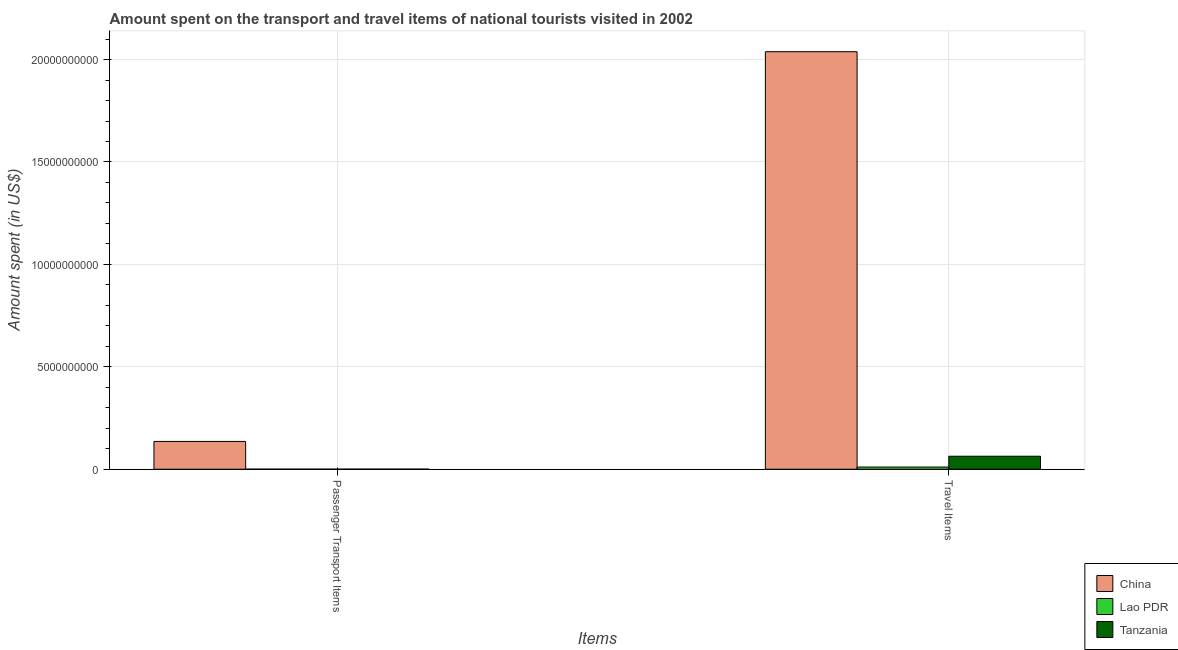Are the number of bars per tick equal to the number of legend labels?
Your answer should be compact. Yes. How many bars are there on the 2nd tick from the left?
Provide a succinct answer. 3. How many bars are there on the 1st tick from the right?
Ensure brevity in your answer.  3. What is the label of the 2nd group of bars from the left?
Provide a succinct answer. Travel Items. What is the amount spent on passenger transport items in China?
Provide a succinct answer. 1.36e+09. Across all countries, what is the maximum amount spent on passenger transport items?
Your answer should be compact. 1.36e+09. Across all countries, what is the minimum amount spent on passenger transport items?
Give a very brief answer. 3.00e+06. In which country was the amount spent on passenger transport items minimum?
Offer a terse response. Lao PDR. What is the total amount spent in travel items in the graph?
Ensure brevity in your answer.  2.11e+1. What is the difference between the amount spent on passenger transport items in China and that in Lao PDR?
Ensure brevity in your answer.  1.35e+09. What is the difference between the amount spent in travel items in Lao PDR and the amount spent on passenger transport items in Tanzania?
Offer a terse response. 1.03e+08. What is the average amount spent on passenger transport items per country?
Ensure brevity in your answer.  4.55e+08. What is the difference between the amount spent on passenger transport items and amount spent in travel items in China?
Ensure brevity in your answer.  -1.90e+1. In how many countries, is the amount spent on passenger transport items greater than 19000000000 US$?
Give a very brief answer. 0. What is the ratio of the amount spent on passenger transport items in Tanzania to that in Lao PDR?
Offer a very short reply. 1.33. What does the 1st bar from the left in Travel Items represents?
Give a very brief answer. China. What does the 3rd bar from the right in Travel Items represents?
Keep it short and to the point. China. How many bars are there?
Your answer should be very brief. 6. Are all the bars in the graph horizontal?
Your answer should be very brief. No. How many countries are there in the graph?
Provide a succinct answer. 3. Does the graph contain any zero values?
Keep it short and to the point. No. Where does the legend appear in the graph?
Your answer should be very brief. Bottom right. What is the title of the graph?
Your answer should be compact. Amount spent on the transport and travel items of national tourists visited in 2002. Does "St. Martin (French part)" appear as one of the legend labels in the graph?
Ensure brevity in your answer.  No. What is the label or title of the X-axis?
Provide a short and direct response. Items. What is the label or title of the Y-axis?
Make the answer very short. Amount spent (in US$). What is the Amount spent (in US$) in China in Passenger Transport Items?
Offer a very short reply. 1.36e+09. What is the Amount spent (in US$) in Lao PDR in Passenger Transport Items?
Offer a very short reply. 3.00e+06. What is the Amount spent (in US$) in China in Travel Items?
Provide a succinct answer. 2.04e+1. What is the Amount spent (in US$) of Lao PDR in Travel Items?
Ensure brevity in your answer.  1.07e+08. What is the Amount spent (in US$) of Tanzania in Travel Items?
Your answer should be very brief. 6.35e+08. Across all Items, what is the maximum Amount spent (in US$) of China?
Make the answer very short. 2.04e+1. Across all Items, what is the maximum Amount spent (in US$) of Lao PDR?
Your response must be concise. 1.07e+08. Across all Items, what is the maximum Amount spent (in US$) in Tanzania?
Provide a short and direct response. 6.35e+08. Across all Items, what is the minimum Amount spent (in US$) in China?
Make the answer very short. 1.36e+09. Across all Items, what is the minimum Amount spent (in US$) in Lao PDR?
Keep it short and to the point. 3.00e+06. Across all Items, what is the minimum Amount spent (in US$) of Tanzania?
Keep it short and to the point. 4.00e+06. What is the total Amount spent (in US$) of China in the graph?
Provide a succinct answer. 2.17e+1. What is the total Amount spent (in US$) of Lao PDR in the graph?
Offer a terse response. 1.10e+08. What is the total Amount spent (in US$) in Tanzania in the graph?
Provide a short and direct response. 6.39e+08. What is the difference between the Amount spent (in US$) in China in Passenger Transport Items and that in Travel Items?
Provide a short and direct response. -1.90e+1. What is the difference between the Amount spent (in US$) in Lao PDR in Passenger Transport Items and that in Travel Items?
Offer a very short reply. -1.04e+08. What is the difference between the Amount spent (in US$) in Tanzania in Passenger Transport Items and that in Travel Items?
Offer a very short reply. -6.31e+08. What is the difference between the Amount spent (in US$) in China in Passenger Transport Items and the Amount spent (in US$) in Lao PDR in Travel Items?
Your answer should be very brief. 1.25e+09. What is the difference between the Amount spent (in US$) of China in Passenger Transport Items and the Amount spent (in US$) of Tanzania in Travel Items?
Ensure brevity in your answer.  7.22e+08. What is the difference between the Amount spent (in US$) in Lao PDR in Passenger Transport Items and the Amount spent (in US$) in Tanzania in Travel Items?
Make the answer very short. -6.32e+08. What is the average Amount spent (in US$) in China per Items?
Offer a very short reply. 1.09e+1. What is the average Amount spent (in US$) of Lao PDR per Items?
Provide a succinct answer. 5.50e+07. What is the average Amount spent (in US$) of Tanzania per Items?
Keep it short and to the point. 3.20e+08. What is the difference between the Amount spent (in US$) of China and Amount spent (in US$) of Lao PDR in Passenger Transport Items?
Ensure brevity in your answer.  1.35e+09. What is the difference between the Amount spent (in US$) in China and Amount spent (in US$) in Tanzania in Passenger Transport Items?
Offer a very short reply. 1.35e+09. What is the difference between the Amount spent (in US$) in Lao PDR and Amount spent (in US$) in Tanzania in Passenger Transport Items?
Offer a terse response. -1.00e+06. What is the difference between the Amount spent (in US$) in China and Amount spent (in US$) in Lao PDR in Travel Items?
Make the answer very short. 2.03e+1. What is the difference between the Amount spent (in US$) in China and Amount spent (in US$) in Tanzania in Travel Items?
Ensure brevity in your answer.  1.98e+1. What is the difference between the Amount spent (in US$) in Lao PDR and Amount spent (in US$) in Tanzania in Travel Items?
Ensure brevity in your answer.  -5.28e+08. What is the ratio of the Amount spent (in US$) in China in Passenger Transport Items to that in Travel Items?
Ensure brevity in your answer.  0.07. What is the ratio of the Amount spent (in US$) of Lao PDR in Passenger Transport Items to that in Travel Items?
Your answer should be very brief. 0.03. What is the ratio of the Amount spent (in US$) in Tanzania in Passenger Transport Items to that in Travel Items?
Offer a very short reply. 0.01. What is the difference between the highest and the second highest Amount spent (in US$) of China?
Provide a short and direct response. 1.90e+1. What is the difference between the highest and the second highest Amount spent (in US$) of Lao PDR?
Your response must be concise. 1.04e+08. What is the difference between the highest and the second highest Amount spent (in US$) of Tanzania?
Your answer should be very brief. 6.31e+08. What is the difference between the highest and the lowest Amount spent (in US$) in China?
Make the answer very short. 1.90e+1. What is the difference between the highest and the lowest Amount spent (in US$) in Lao PDR?
Your answer should be very brief. 1.04e+08. What is the difference between the highest and the lowest Amount spent (in US$) in Tanzania?
Your response must be concise. 6.31e+08. 